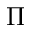Convert formula to latex. <formula><loc_0><loc_0><loc_500><loc_500>\Pi</formula> 